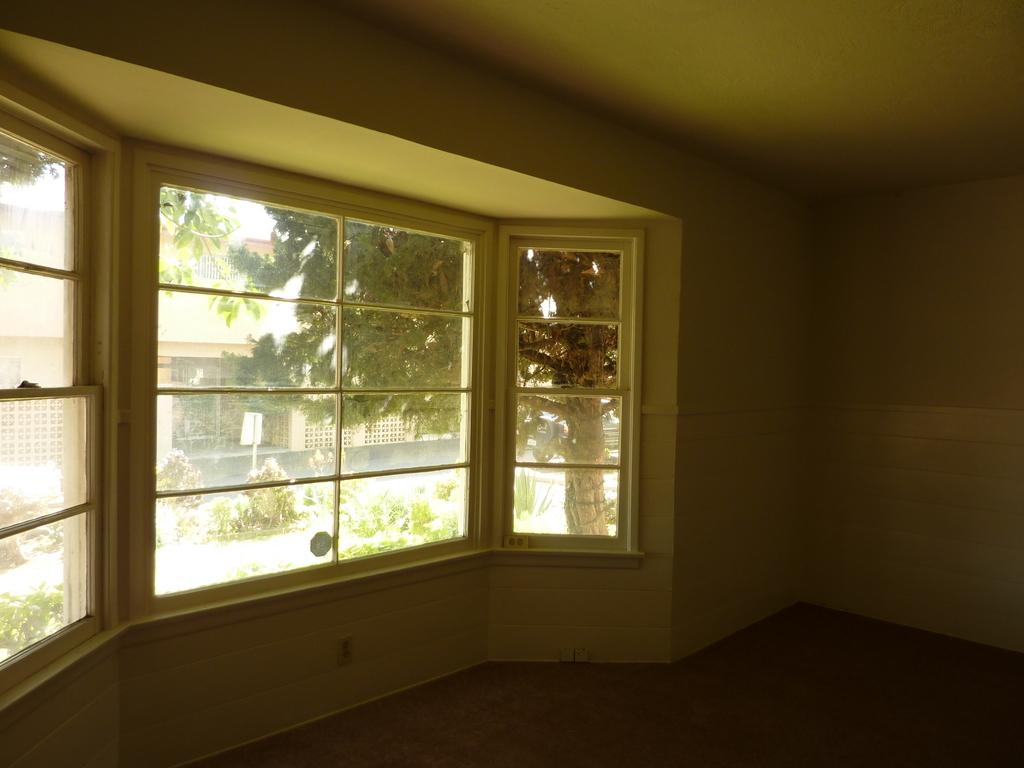What type of structures are present in the image? There are buildings in the image. What feature do the buildings have? The buildings have glass windows. What colors are used on the wall in the image? The wall is in white and green color. What can be seen in the background of the image? There are trees and a white color board visible in the background. What type of station can be seen in the image? There is no station present in the image. Is there a farmer working in the background of the image? There is no farmer present in the image. 